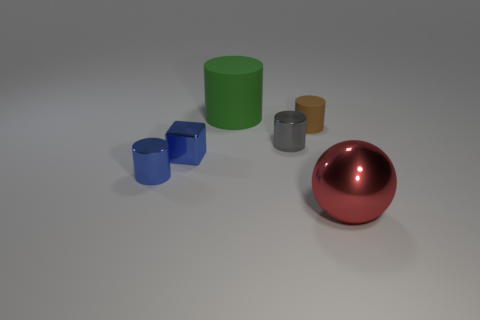Subtract all blue metallic cylinders. How many cylinders are left? 3 Subtract all blue cylinders. How many cylinders are left? 3 Add 1 spheres. How many objects exist? 7 Subtract all balls. How many objects are left? 5 Subtract all blue cylinders. Subtract all brown balls. How many cylinders are left? 3 Add 4 blue metallic blocks. How many blue metallic blocks are left? 5 Add 5 red things. How many red things exist? 6 Subtract 0 cyan spheres. How many objects are left? 6 Subtract all brown matte cylinders. Subtract all blue objects. How many objects are left? 3 